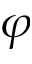Convert formula to latex. <formula><loc_0><loc_0><loc_500><loc_500>\varphi</formula> 